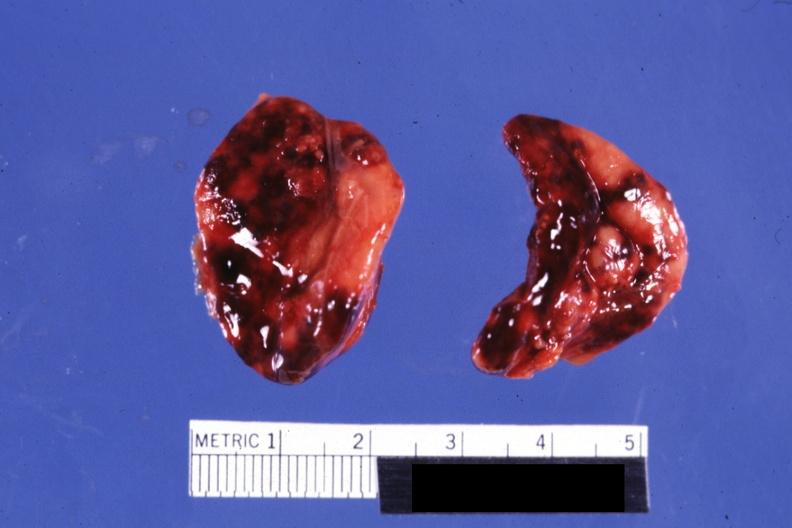what does this image adrenal?
Answer the question using a single word or phrase. Both adrenals external views focal hemorrhages do not know history looks like placental abruption 